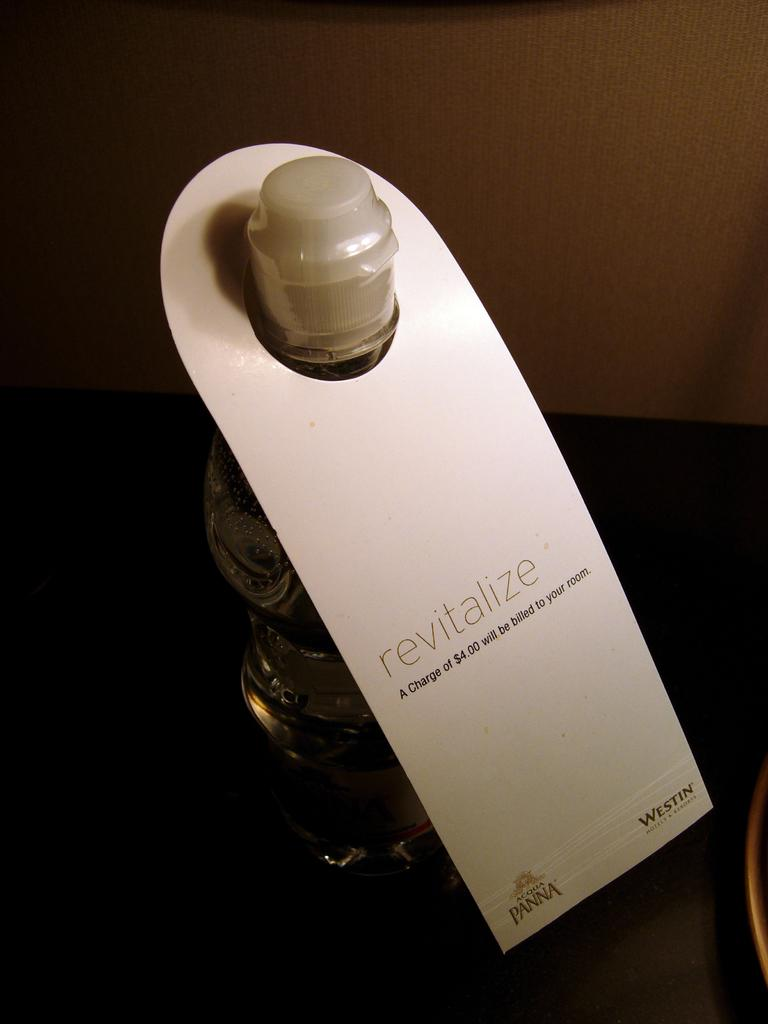<image>
Share a concise interpretation of the image provided. A bottle of Revitalize sits on a table top in a hotel room. 